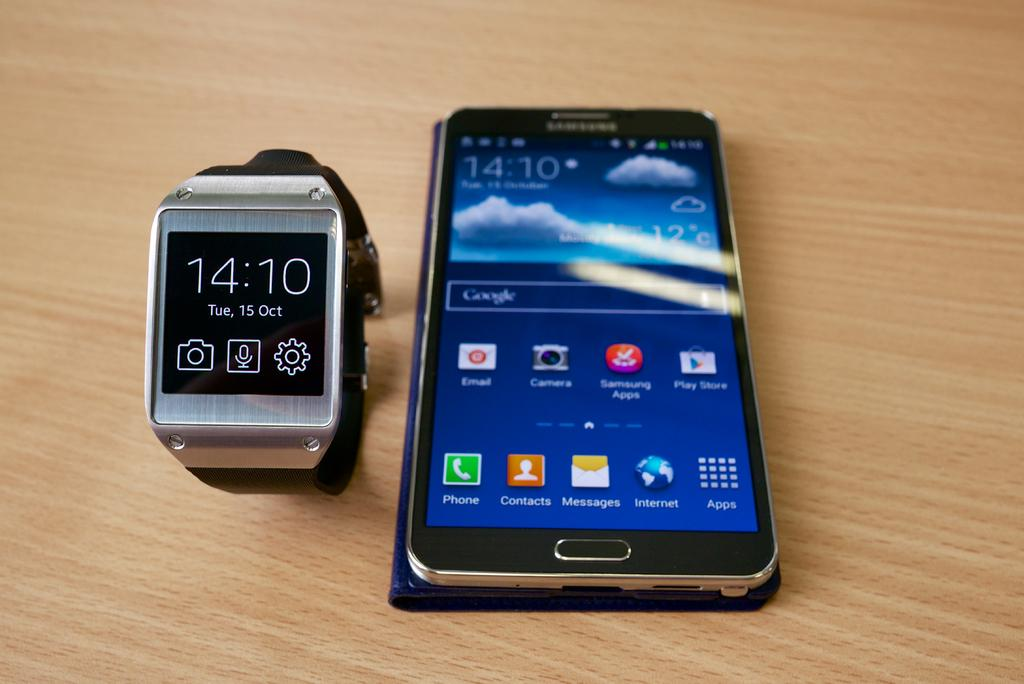<image>
Offer a succinct explanation of the picture presented. A watch showing the date of Tuesday, October 15th is sitting on a table next to a smartphone. 